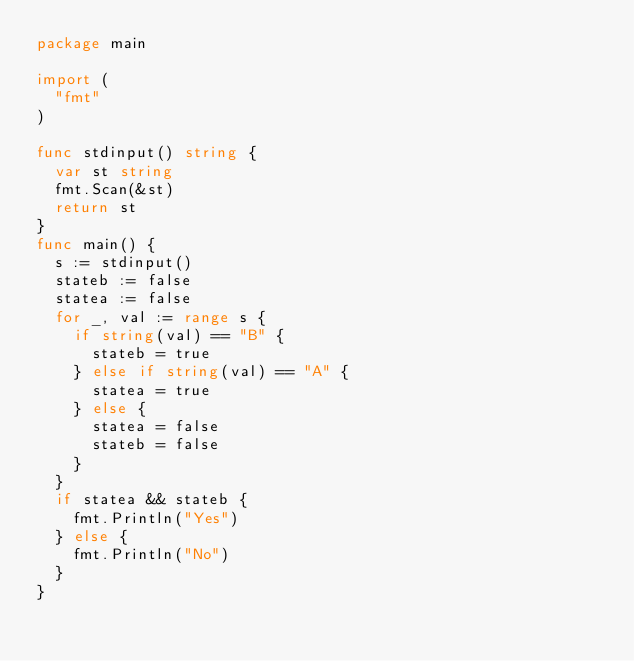Convert code to text. <code><loc_0><loc_0><loc_500><loc_500><_Go_>package main

import (
	"fmt"
)

func stdinput() string {
	var st string
	fmt.Scan(&st)
	return st
}
func main() {
	s := stdinput()
	stateb := false
	statea := false
	for _, val := range s {
		if string(val) == "B" {
			stateb = true
		} else if string(val) == "A" {
			statea = true
		} else {
			statea = false
			stateb = false
		}
	}
	if statea && stateb {
		fmt.Println("Yes")
	} else {
		fmt.Println("No")
	}
}</code> 